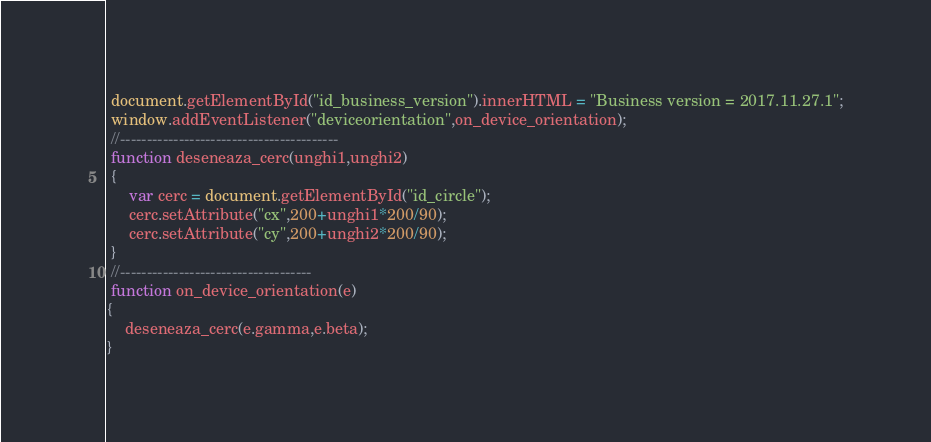<code> <loc_0><loc_0><loc_500><loc_500><_JavaScript_> document.getElementById("id_business_version").innerHTML = "Business version = 2017.11.27.1";
 window.addEventListener("deviceorientation",on_device_orientation);
 //-----------------------------------------
 function deseneaza_cerc(unghi1,unghi2)
 {
	 var cerc = document.getElementById("id_circle");
	 cerc.setAttribute("cx",200+unghi1*200/90);
	 cerc.setAttribute("cy",200+unghi2*200/90);
 }
 //------------------------------------
 function on_device_orientation(e)
{
	deseneaza_cerc(e.gamma,e.beta);
}</code> 